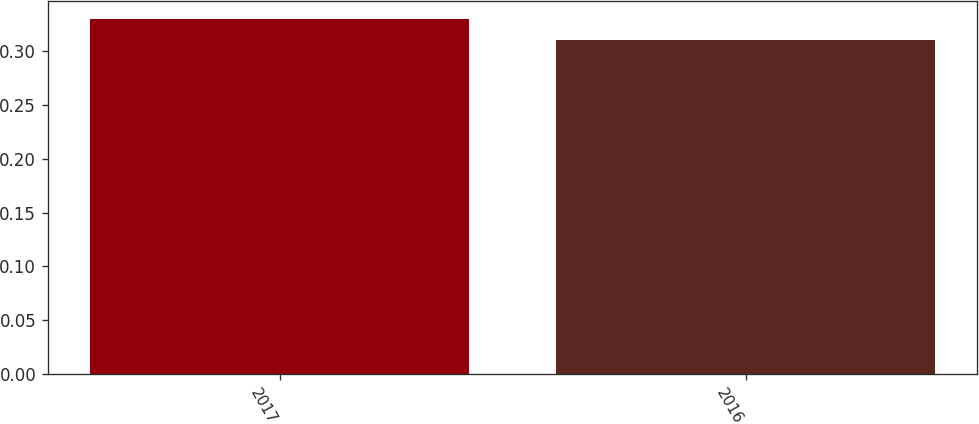Convert chart. <chart><loc_0><loc_0><loc_500><loc_500><bar_chart><fcel>2017<fcel>2016<nl><fcel>0.33<fcel>0.31<nl></chart> 